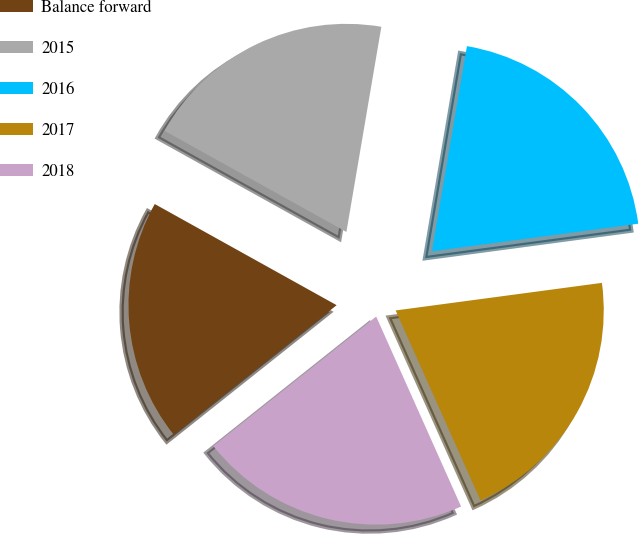Convert chart. <chart><loc_0><loc_0><loc_500><loc_500><pie_chart><fcel>Balance forward<fcel>2015<fcel>2016<fcel>2017<fcel>2018<nl><fcel>18.77%<fcel>19.61%<fcel>20.2%<fcel>20.43%<fcel>21.0%<nl></chart> 